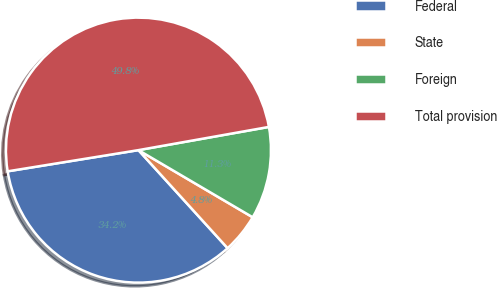<chart> <loc_0><loc_0><loc_500><loc_500><pie_chart><fcel>Federal<fcel>State<fcel>Foreign<fcel>Total provision<nl><fcel>34.19%<fcel>4.8%<fcel>11.26%<fcel>49.76%<nl></chart> 